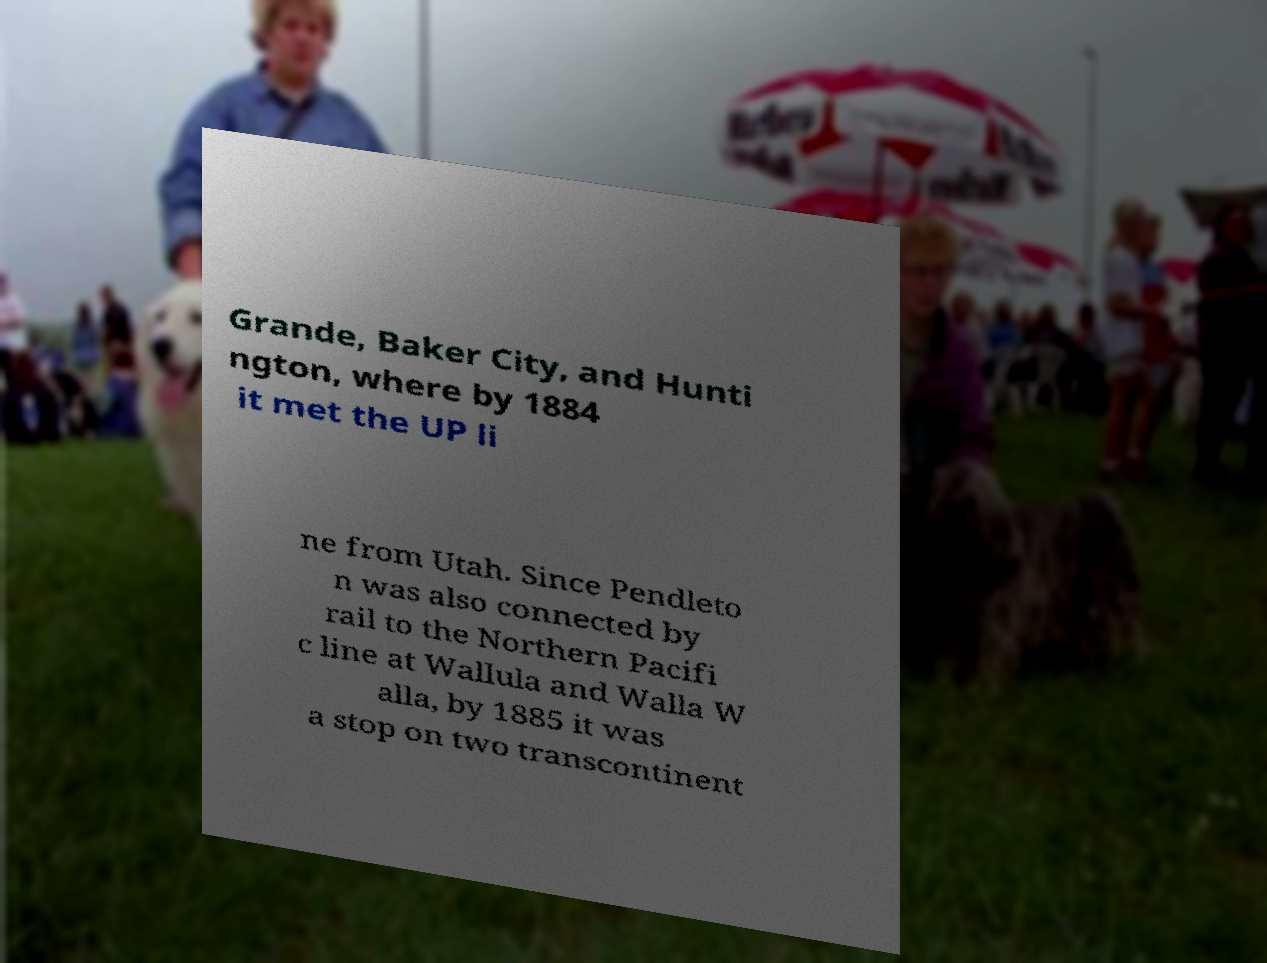What messages or text are displayed in this image? I need them in a readable, typed format. Grande, Baker City, and Hunti ngton, where by 1884 it met the UP li ne from Utah. Since Pendleto n was also connected by rail to the Northern Pacifi c line at Wallula and Walla W alla, by 1885 it was a stop on two transcontinent 